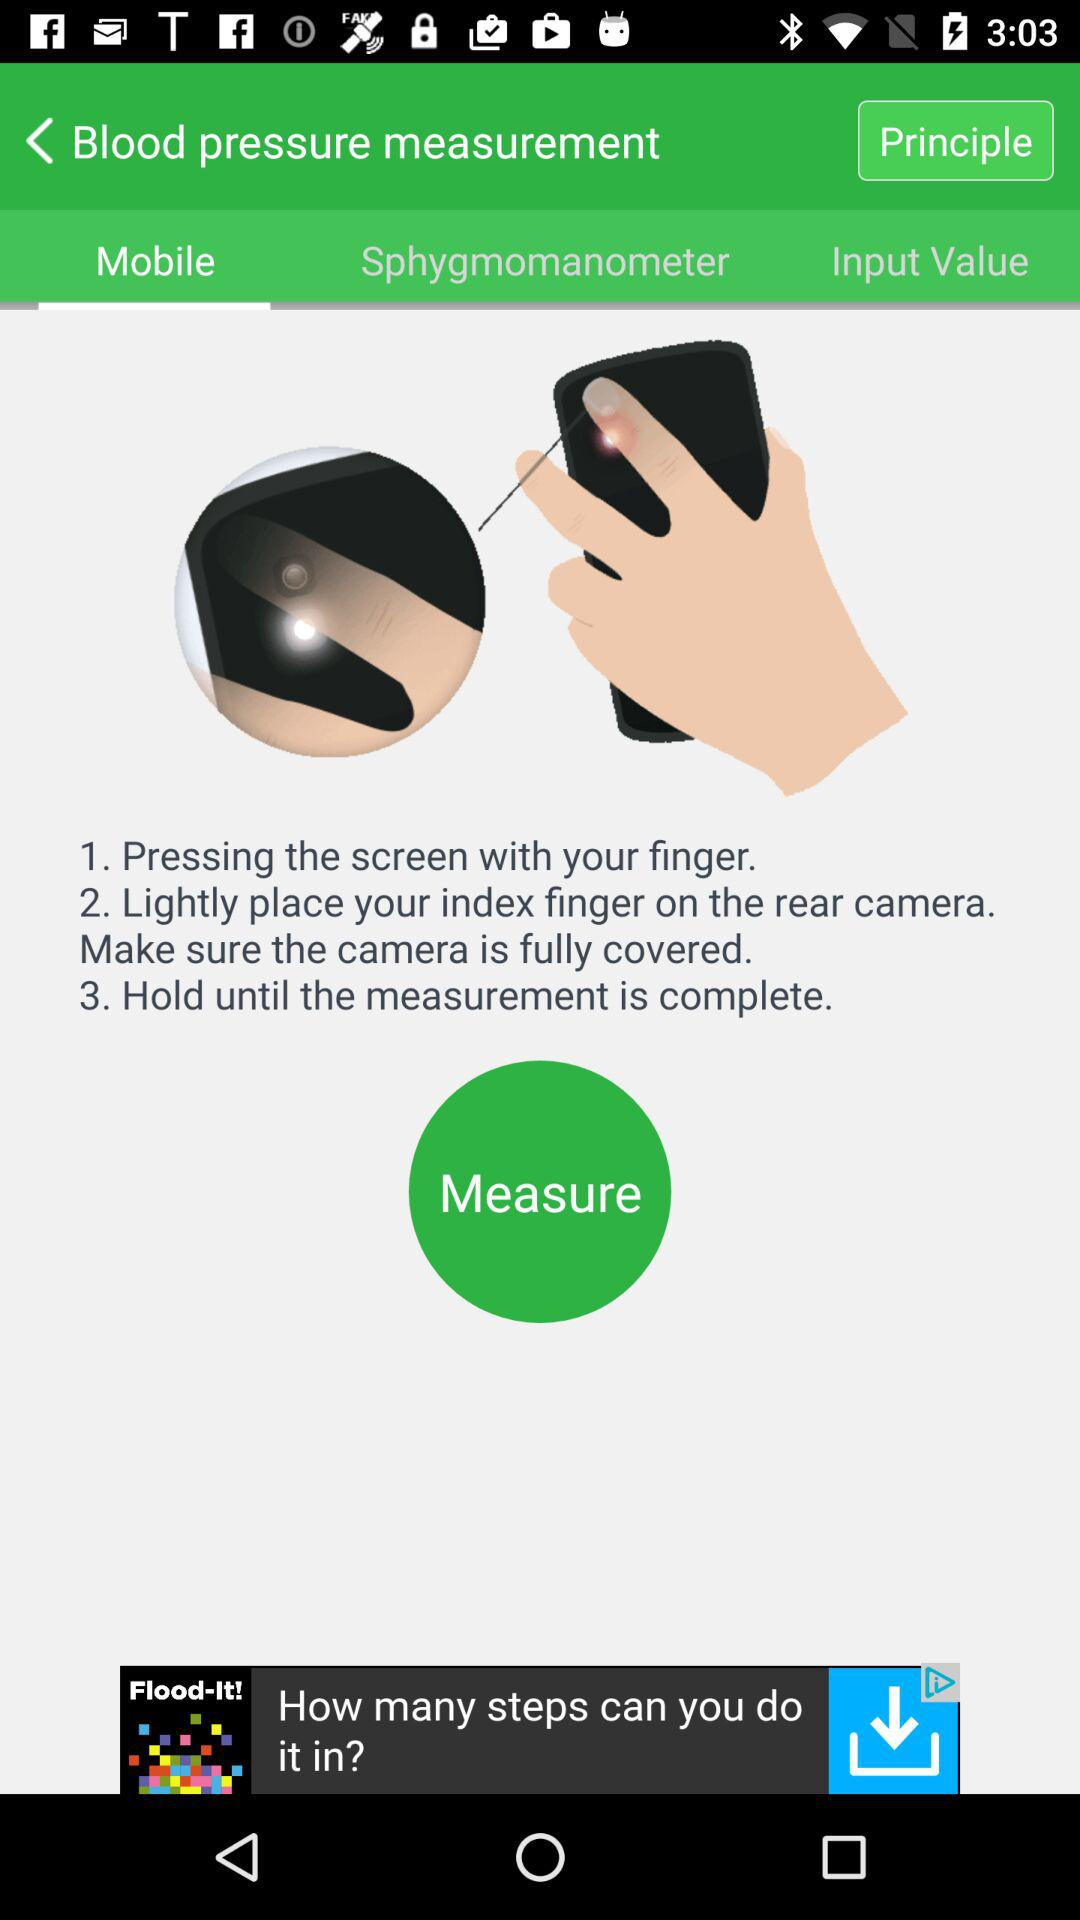Which tab am I on? You are on the "Mobile" tab. 